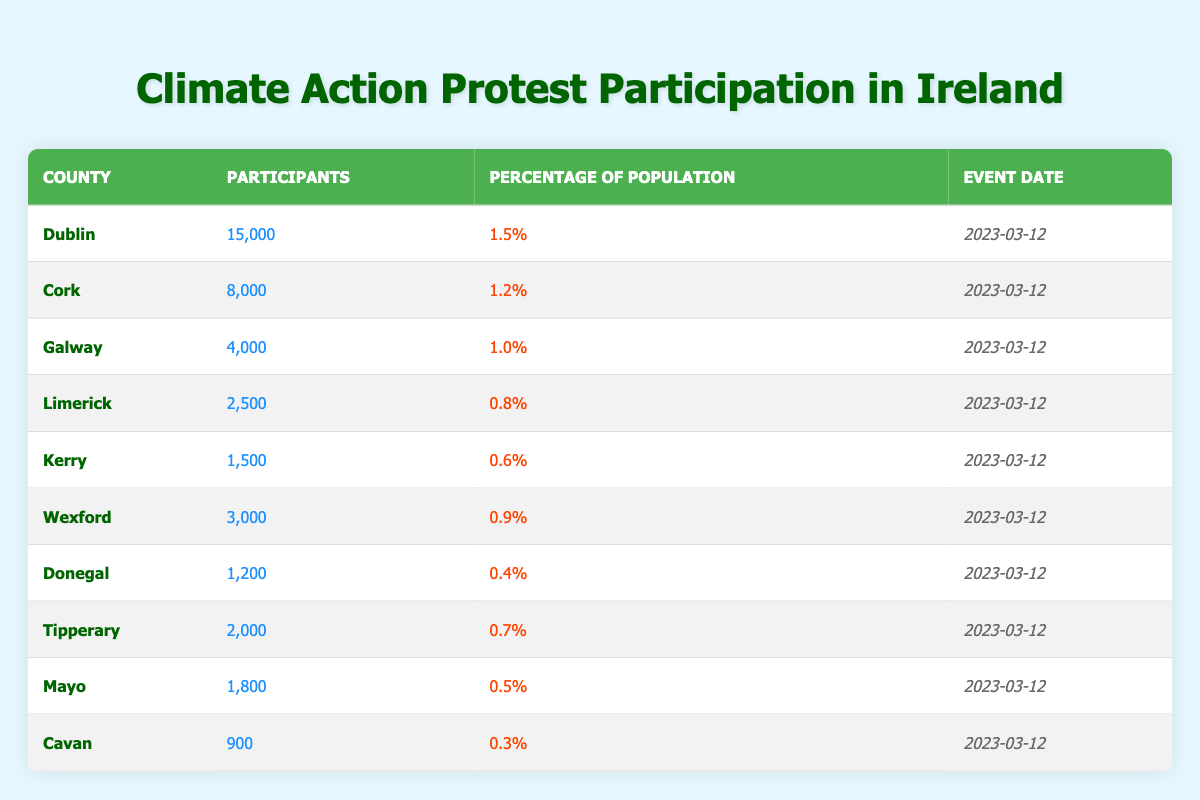What county had the highest number of participants? By examining the participants column in the table, we can see that Dublin had 15,000 participants, which is the highest number among all listed counties.
Answer: Dublin What percentage of the population participated in the climate action protest in Galway? According to the table, Galway had a participation percentage of 1.0% listed in the percentage of population column.
Answer: 1.0% How many more participants attended the protest in Cork compared to Limerick? Cork had 8,000 participants while Limerick had 2,500 participants. Subtracting Limerick's participants from Cork's (8,000 - 2,500) gives us 5,500 more participants.
Answer: 5,500 What is the average percentage of population participating in the protest across all counties listed? To find the average, we sum the percentages: (1.5 + 1.2 + 1.0 + 0.8 + 0.6 + 0.9 + 0.4 + 0.7 + 0.5 + 0.3) = 7.6%. There are 10 counties, so the average is 7.6% / 10 = 0.76%.
Answer: 0.76% Did any county have a participation percentage above 1%? By reviewing the percentage of population column, Dublin (1.5%) and Cork (1.2%) are both above 1%. Therefore, the answer is yes.
Answer: Yes Which county had the lowest participation in the protest? Looking at the participants column, Donegal had 1,200 participants, which is the lowest compared to the other counties.
Answer: Donegal If we combine the participation from Kieran and Tipperary, how many participants were there? Kieran had 1,500 participants and Tipperary had 2,000 participants. Adding these together (1,500 + 2,000) gives us 3,500 total participants for those two counties.
Answer: 3,500 True or False: More than 2,000 participants attended the protest in Kerry. The table shows that Kerry had 1,500 participants, which is not more than 2,000, so the statement is false.
Answer: False What is the total number of participants from all counties listed in the table? To find the total, we sum up the participants from all counties: 15,000 + 8,000 + 4,000 + 2,500 + 1,500 + 3,000 + 1,200 + 2,000 + 1,800 + 900 = 38,900 participants in total.
Answer: 38,900 